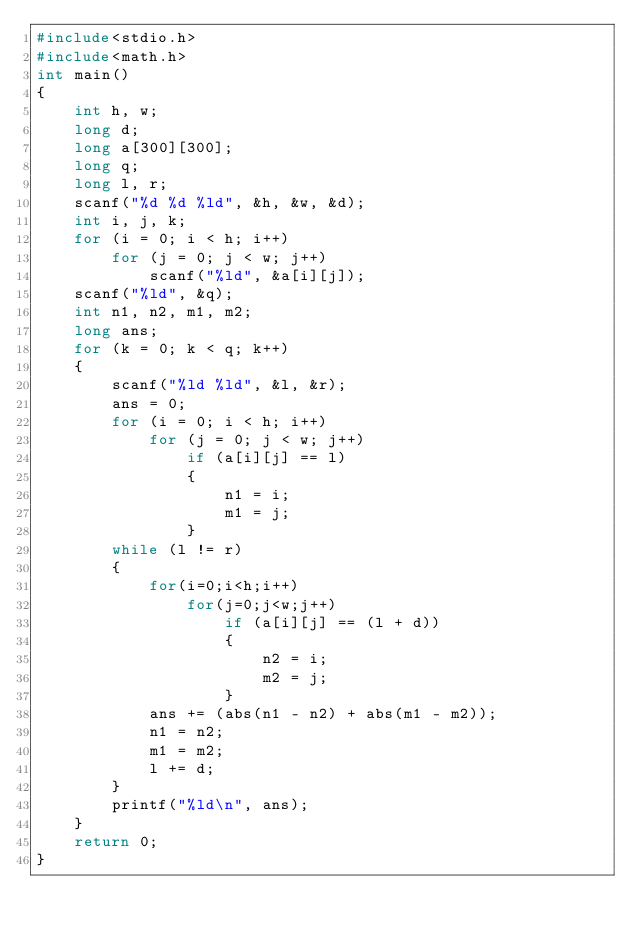Convert code to text. <code><loc_0><loc_0><loc_500><loc_500><_C_>#include<stdio.h>
#include<math.h>
int main()
{
    int h, w;
    long d;
    long a[300][300];
    long q;
    long l, r;
    scanf("%d %d %ld", &h, &w, &d);
    int i, j, k;
    for (i = 0; i < h; i++)
        for (j = 0; j < w; j++)
            scanf("%ld", &a[i][j]);
    scanf("%ld", &q);
    int n1, n2, m1, m2;
    long ans;
    for (k = 0; k < q; k++)
    {
        scanf("%ld %ld", &l, &r);
        ans = 0;
        for (i = 0; i < h; i++)
            for (j = 0; j < w; j++)
                if (a[i][j] == l)
                {
                    n1 = i;
                    m1 = j;
                }
        while (l != r)
        {
            for(i=0;i<h;i++)
                for(j=0;j<w;j++)
                    if (a[i][j] == (l + d))
                    {
                        n2 = i;
                        m2 = j;
                    }
            ans += (abs(n1 - n2) + abs(m1 - m2));
            n1 = n2;
            m1 = m2;
            l += d;
        }
        printf("%ld\n", ans);
    }
    return 0;
}</code> 